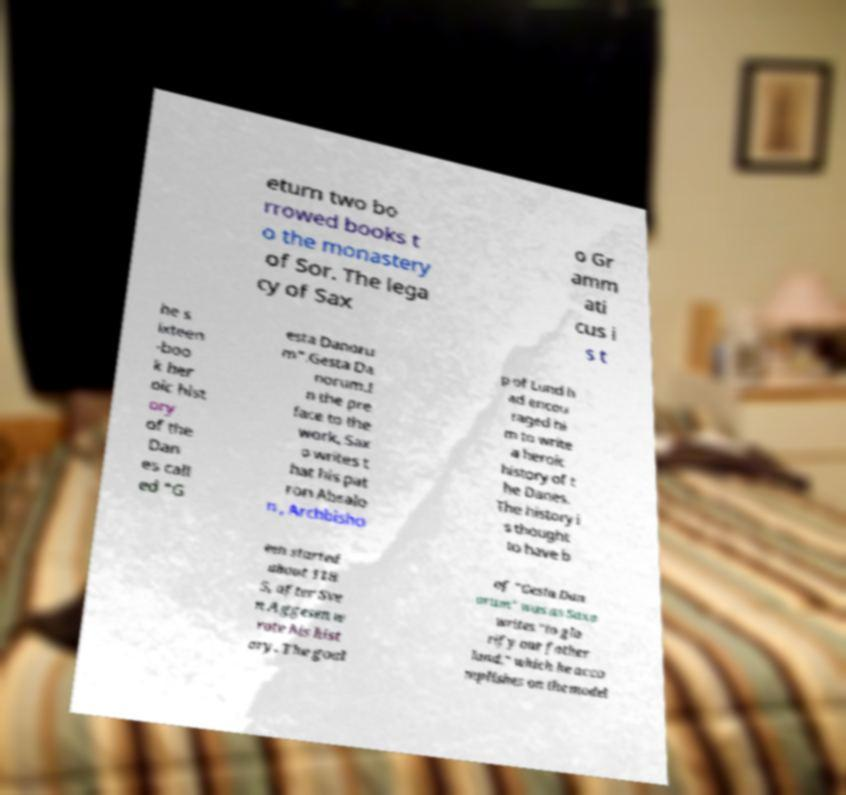Could you extract and type out the text from this image? eturn two bo rrowed books t o the monastery of Sor. The lega cy of Sax o Gr amm ati cus i s t he s ixteen -boo k her oic hist ory of the Dan es call ed "G esta Danoru m".Gesta Da norum.I n the pre face to the work, Sax o writes t hat his pat ron Absalo n , Archbisho p of Lund h ad encou raged hi m to write a heroic history of t he Danes. The history i s thought to have b een started about 118 5, after Sve n Aggesen w rote his hist ory. The goal of "Gesta Dan orum" was as Saxo writes "to glo rify our father land," which he acco mplishes on the model 